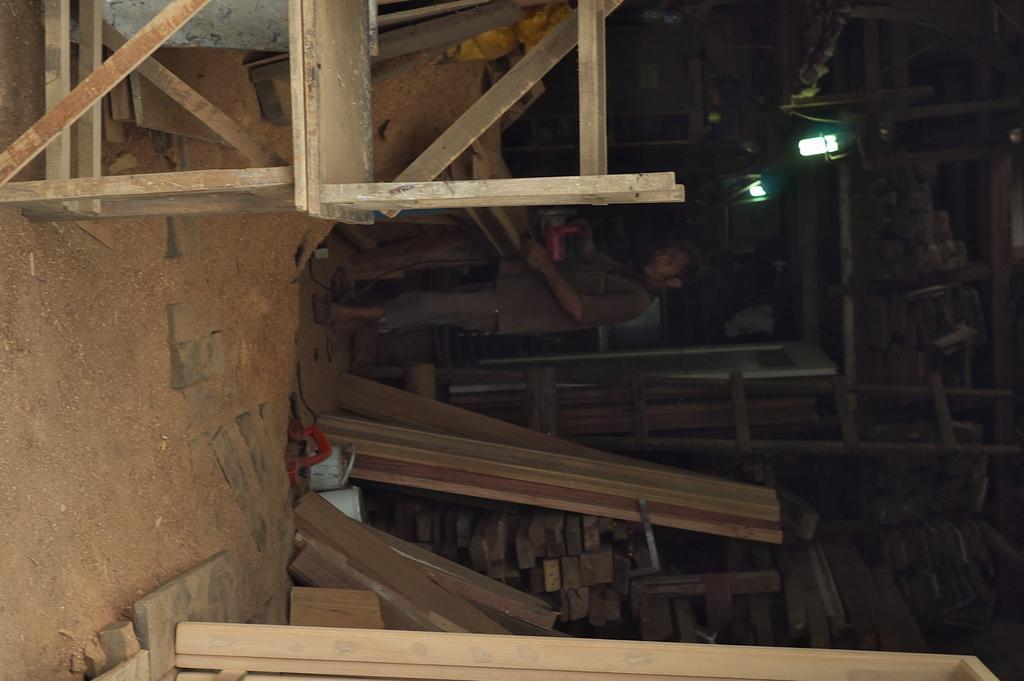Could you give a brief overview of what you see in this image? This picture shows couple of tables and we see a man cutting wood with the machine and we see lights and pile of woods in the shelf and wooden planks on the ground. 